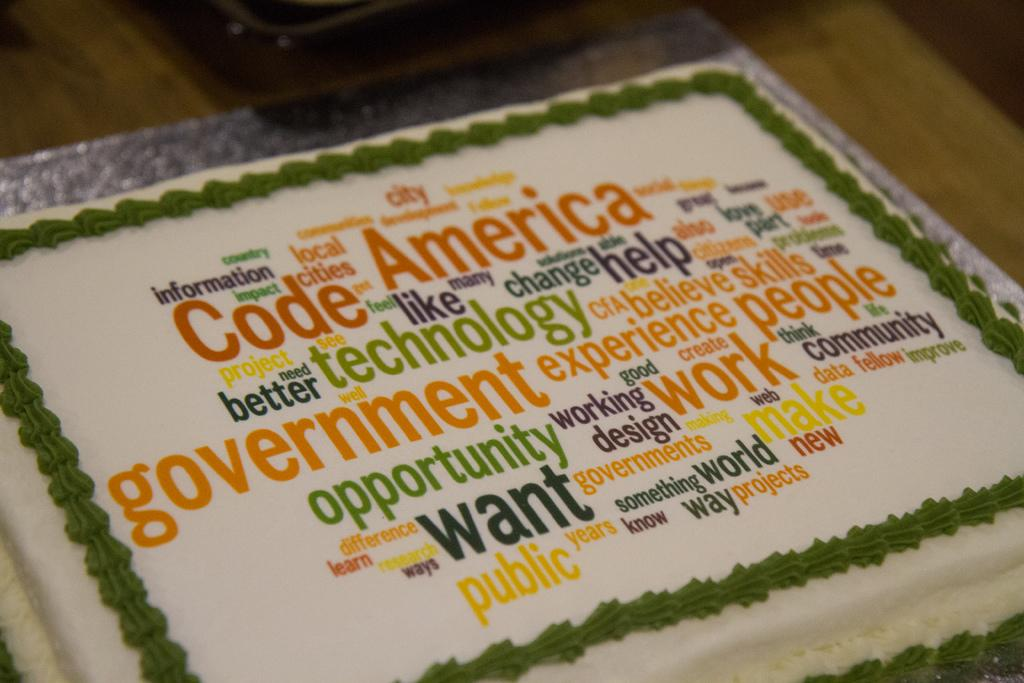What is the main subject of the image? The main subject of the image is a cake. Where is the cake located in the image? The cake is on a surface in the image. What additional detail can be observed on the cake? There is text on the cake. What type of war is depicted in the image? There is no depiction of war in the image; it features a cake with text on it. Can you describe the harbor visible in the image? There is no harbor present in the image; it only shows a cake on a surface with text. 